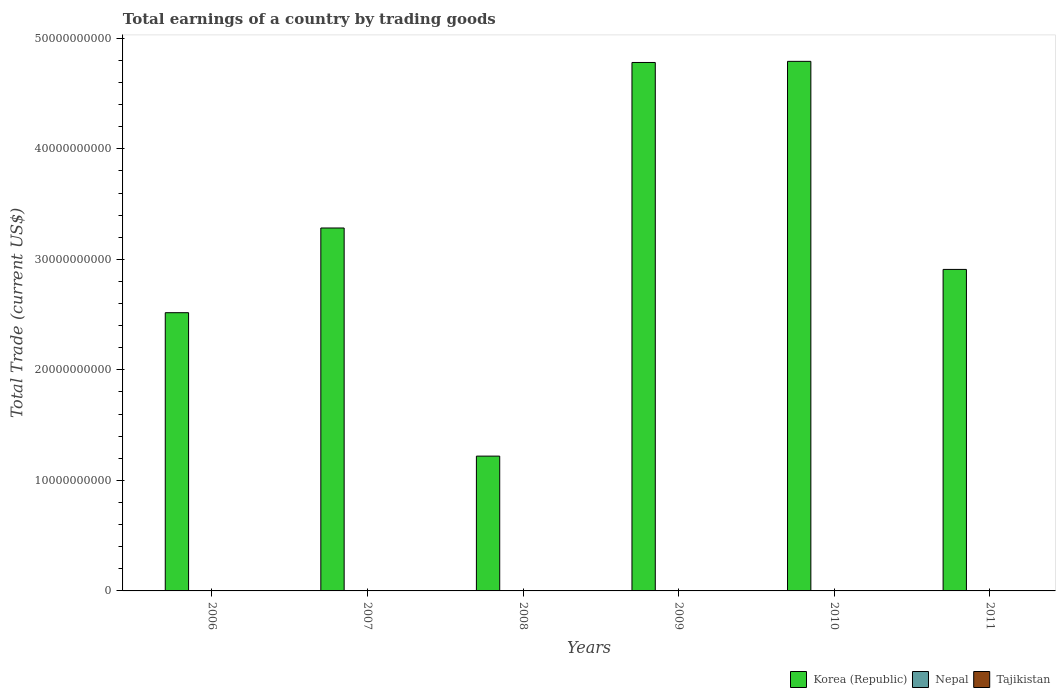How many different coloured bars are there?
Give a very brief answer. 1. Are the number of bars per tick equal to the number of legend labels?
Your response must be concise. No. Are the number of bars on each tick of the X-axis equal?
Your answer should be compact. Yes. How many bars are there on the 2nd tick from the left?
Your answer should be very brief. 1. What is the total earnings in Korea (Republic) in 2011?
Offer a terse response. 2.91e+1. Across all years, what is the maximum total earnings in Korea (Republic)?
Provide a succinct answer. 4.79e+1. In which year was the total earnings in Korea (Republic) maximum?
Your response must be concise. 2010. What is the difference between the total earnings in Korea (Republic) in 2010 and that in 2011?
Provide a succinct answer. 1.88e+1. What is the difference between the total earnings in Nepal in 2009 and the total earnings in Korea (Republic) in 2006?
Your answer should be compact. -2.52e+1. What is the average total earnings in Korea (Republic) per year?
Offer a very short reply. 3.25e+1. What is the ratio of the total earnings in Korea (Republic) in 2008 to that in 2010?
Offer a very short reply. 0.25. Is the total earnings in Korea (Republic) in 2007 less than that in 2009?
Offer a terse response. Yes. What is the difference between the highest and the second highest total earnings in Korea (Republic)?
Provide a short and direct response. 1.01e+08. What is the difference between the highest and the lowest total earnings in Korea (Republic)?
Keep it short and to the point. 3.57e+1. Are the values on the major ticks of Y-axis written in scientific E-notation?
Provide a short and direct response. No. Does the graph contain any zero values?
Make the answer very short. Yes. Does the graph contain grids?
Your answer should be very brief. No. Where does the legend appear in the graph?
Your response must be concise. Bottom right. How many legend labels are there?
Offer a very short reply. 3. What is the title of the graph?
Keep it short and to the point. Total earnings of a country by trading goods. Does "Euro area" appear as one of the legend labels in the graph?
Your response must be concise. No. What is the label or title of the X-axis?
Offer a very short reply. Years. What is the label or title of the Y-axis?
Give a very brief answer. Total Trade (current US$). What is the Total Trade (current US$) of Korea (Republic) in 2006?
Provide a succinct answer. 2.52e+1. What is the Total Trade (current US$) of Nepal in 2006?
Give a very brief answer. 0. What is the Total Trade (current US$) of Korea (Republic) in 2007?
Provide a short and direct response. 3.28e+1. What is the Total Trade (current US$) of Nepal in 2007?
Your answer should be compact. 0. What is the Total Trade (current US$) in Tajikistan in 2007?
Ensure brevity in your answer.  0. What is the Total Trade (current US$) of Korea (Republic) in 2008?
Give a very brief answer. 1.22e+1. What is the Total Trade (current US$) of Nepal in 2008?
Provide a short and direct response. 0. What is the Total Trade (current US$) in Tajikistan in 2008?
Provide a succinct answer. 0. What is the Total Trade (current US$) of Korea (Republic) in 2009?
Give a very brief answer. 4.78e+1. What is the Total Trade (current US$) of Nepal in 2009?
Offer a very short reply. 0. What is the Total Trade (current US$) of Korea (Republic) in 2010?
Your answer should be very brief. 4.79e+1. What is the Total Trade (current US$) in Nepal in 2010?
Your answer should be compact. 0. What is the Total Trade (current US$) of Tajikistan in 2010?
Provide a succinct answer. 0. What is the Total Trade (current US$) in Korea (Republic) in 2011?
Ensure brevity in your answer.  2.91e+1. Across all years, what is the maximum Total Trade (current US$) in Korea (Republic)?
Give a very brief answer. 4.79e+1. Across all years, what is the minimum Total Trade (current US$) in Korea (Republic)?
Give a very brief answer. 1.22e+1. What is the total Total Trade (current US$) of Korea (Republic) in the graph?
Your response must be concise. 1.95e+11. What is the total Total Trade (current US$) of Nepal in the graph?
Your response must be concise. 0. What is the difference between the Total Trade (current US$) of Korea (Republic) in 2006 and that in 2007?
Make the answer very short. -7.66e+09. What is the difference between the Total Trade (current US$) in Korea (Republic) in 2006 and that in 2008?
Ensure brevity in your answer.  1.30e+1. What is the difference between the Total Trade (current US$) of Korea (Republic) in 2006 and that in 2009?
Give a very brief answer. -2.26e+1. What is the difference between the Total Trade (current US$) in Korea (Republic) in 2006 and that in 2010?
Your answer should be very brief. -2.27e+1. What is the difference between the Total Trade (current US$) of Korea (Republic) in 2006 and that in 2011?
Provide a short and direct response. -3.92e+09. What is the difference between the Total Trade (current US$) of Korea (Republic) in 2007 and that in 2008?
Offer a terse response. 2.06e+1. What is the difference between the Total Trade (current US$) of Korea (Republic) in 2007 and that in 2009?
Offer a very short reply. -1.50e+1. What is the difference between the Total Trade (current US$) of Korea (Republic) in 2007 and that in 2010?
Ensure brevity in your answer.  -1.51e+1. What is the difference between the Total Trade (current US$) in Korea (Republic) in 2007 and that in 2011?
Ensure brevity in your answer.  3.75e+09. What is the difference between the Total Trade (current US$) of Korea (Republic) in 2008 and that in 2009?
Your response must be concise. -3.56e+1. What is the difference between the Total Trade (current US$) in Korea (Republic) in 2008 and that in 2010?
Ensure brevity in your answer.  -3.57e+1. What is the difference between the Total Trade (current US$) in Korea (Republic) in 2008 and that in 2011?
Your answer should be compact. -1.69e+1. What is the difference between the Total Trade (current US$) of Korea (Republic) in 2009 and that in 2010?
Provide a short and direct response. -1.01e+08. What is the difference between the Total Trade (current US$) in Korea (Republic) in 2009 and that in 2011?
Your answer should be compact. 1.87e+1. What is the difference between the Total Trade (current US$) of Korea (Republic) in 2010 and that in 2011?
Provide a short and direct response. 1.88e+1. What is the average Total Trade (current US$) of Korea (Republic) per year?
Offer a terse response. 3.25e+1. What is the average Total Trade (current US$) in Nepal per year?
Provide a short and direct response. 0. What is the average Total Trade (current US$) in Tajikistan per year?
Offer a very short reply. 0. What is the ratio of the Total Trade (current US$) of Korea (Republic) in 2006 to that in 2007?
Offer a very short reply. 0.77. What is the ratio of the Total Trade (current US$) in Korea (Republic) in 2006 to that in 2008?
Give a very brief answer. 2.06. What is the ratio of the Total Trade (current US$) of Korea (Republic) in 2006 to that in 2009?
Your answer should be compact. 0.53. What is the ratio of the Total Trade (current US$) of Korea (Republic) in 2006 to that in 2010?
Make the answer very short. 0.53. What is the ratio of the Total Trade (current US$) in Korea (Republic) in 2006 to that in 2011?
Your response must be concise. 0.87. What is the ratio of the Total Trade (current US$) in Korea (Republic) in 2007 to that in 2008?
Offer a terse response. 2.69. What is the ratio of the Total Trade (current US$) of Korea (Republic) in 2007 to that in 2009?
Provide a short and direct response. 0.69. What is the ratio of the Total Trade (current US$) of Korea (Republic) in 2007 to that in 2010?
Ensure brevity in your answer.  0.69. What is the ratio of the Total Trade (current US$) in Korea (Republic) in 2007 to that in 2011?
Your answer should be compact. 1.13. What is the ratio of the Total Trade (current US$) of Korea (Republic) in 2008 to that in 2009?
Ensure brevity in your answer.  0.26. What is the ratio of the Total Trade (current US$) of Korea (Republic) in 2008 to that in 2010?
Give a very brief answer. 0.25. What is the ratio of the Total Trade (current US$) of Korea (Republic) in 2008 to that in 2011?
Make the answer very short. 0.42. What is the ratio of the Total Trade (current US$) in Korea (Republic) in 2009 to that in 2011?
Your answer should be very brief. 1.64. What is the ratio of the Total Trade (current US$) of Korea (Republic) in 2010 to that in 2011?
Ensure brevity in your answer.  1.65. What is the difference between the highest and the second highest Total Trade (current US$) in Korea (Republic)?
Offer a terse response. 1.01e+08. What is the difference between the highest and the lowest Total Trade (current US$) of Korea (Republic)?
Make the answer very short. 3.57e+1. 